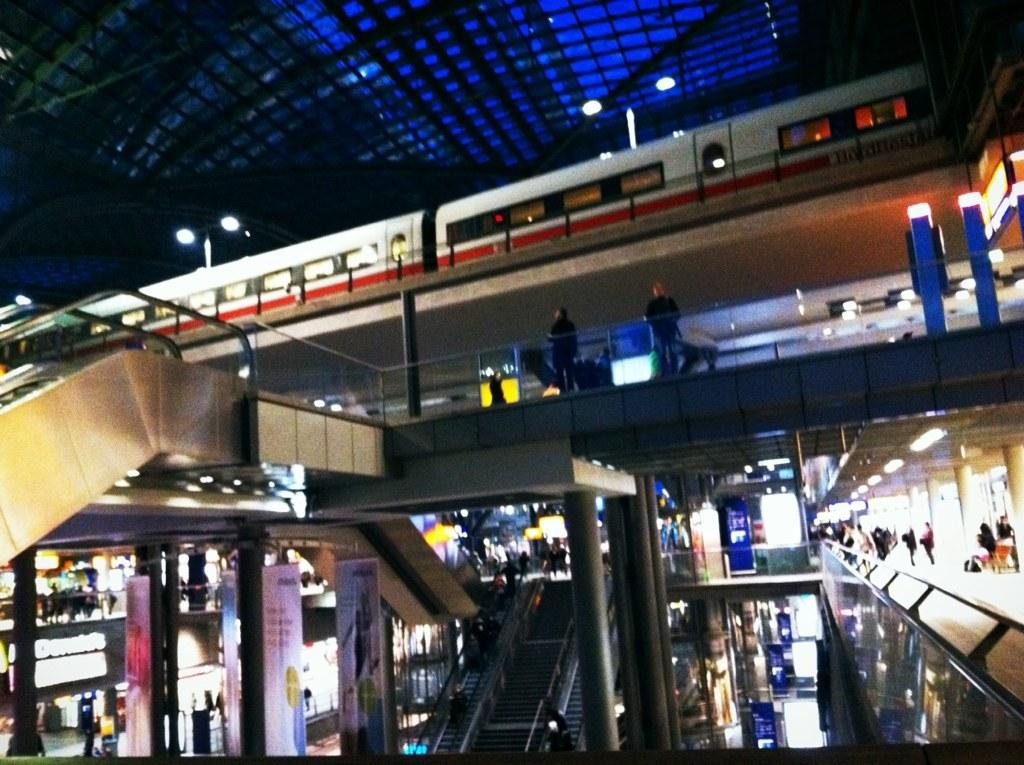What is the main subject of the image? The main subject of the image is a train. What type of transportation infrastructure is present in the image? There are escalators in the image. Can you describe the people in the image? There are people standing and seated in the image. What other features can be seen in the image? There are lights visible and banners hanging in the image. What type of invention is being demonstrated by the tomatoes in the image? There are no tomatoes present in the image, and therefore no invention can be demonstrated by them. 